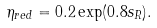<formula> <loc_0><loc_0><loc_500><loc_500>\eta _ { r e d } = 0 . 2 \exp ( 0 . 8 s _ { R } ) .</formula> 